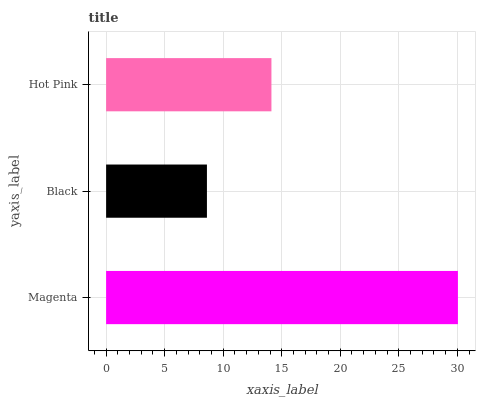Is Black the minimum?
Answer yes or no. Yes. Is Magenta the maximum?
Answer yes or no. Yes. Is Hot Pink the minimum?
Answer yes or no. No. Is Hot Pink the maximum?
Answer yes or no. No. Is Hot Pink greater than Black?
Answer yes or no. Yes. Is Black less than Hot Pink?
Answer yes or no. Yes. Is Black greater than Hot Pink?
Answer yes or no. No. Is Hot Pink less than Black?
Answer yes or no. No. Is Hot Pink the high median?
Answer yes or no. Yes. Is Hot Pink the low median?
Answer yes or no. Yes. Is Black the high median?
Answer yes or no. No. Is Black the low median?
Answer yes or no. No. 